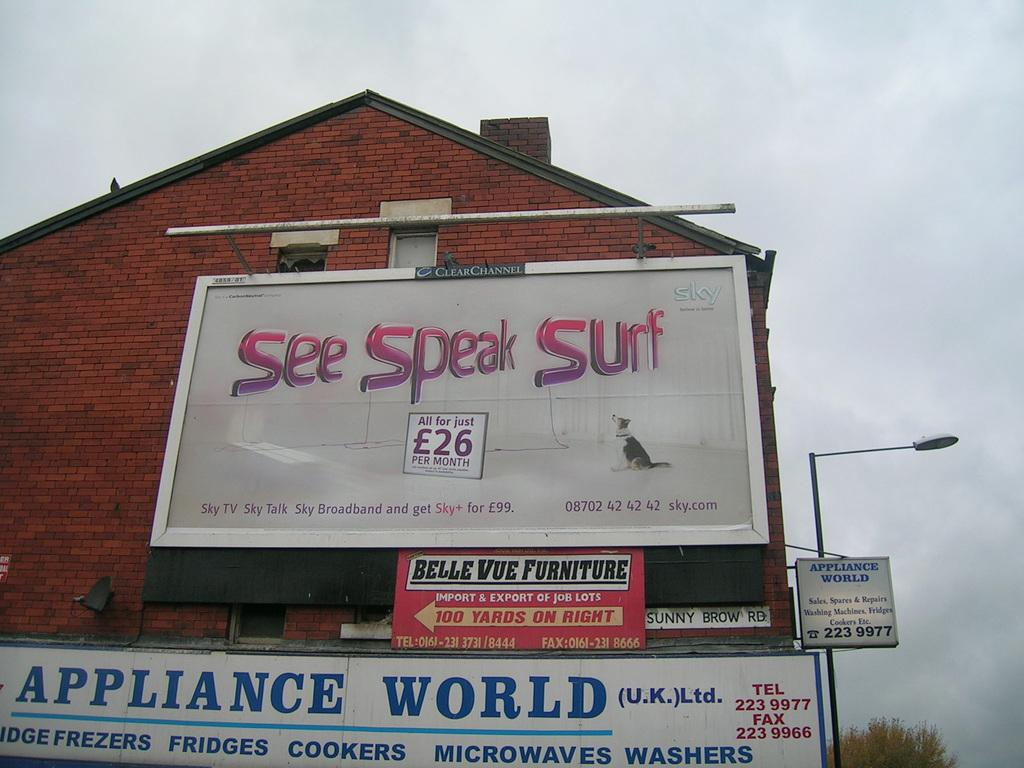<image>
Offer a succinct explanation of the picture presented. Multiple business signs with references to Appliance World, Sky.com and Belle Vue Furniture. 